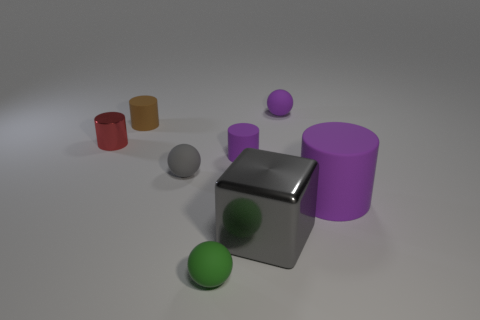What is the shape of the red object?
Your answer should be compact. Cylinder. Are there any small cylinders that have the same color as the big metal thing?
Make the answer very short. No. Is the number of red shiny cylinders that are on the right side of the tiny shiny thing greater than the number of small matte objects?
Your response must be concise. No. Is the shape of the gray metallic object the same as the purple rubber object left of the purple sphere?
Your response must be concise. No. Is there a small rubber ball?
Your answer should be very brief. Yes. What number of tiny things are brown shiny spheres or matte balls?
Provide a short and direct response. 3. Is the number of small red things that are to the right of the small purple cylinder greater than the number of purple cylinders on the left side of the big gray metallic block?
Your response must be concise. No. Are the large purple object and the tiny ball that is on the left side of the tiny green rubber ball made of the same material?
Provide a short and direct response. Yes. The large block is what color?
Make the answer very short. Gray. What shape is the shiny thing on the right side of the green matte sphere?
Keep it short and to the point. Cube. 